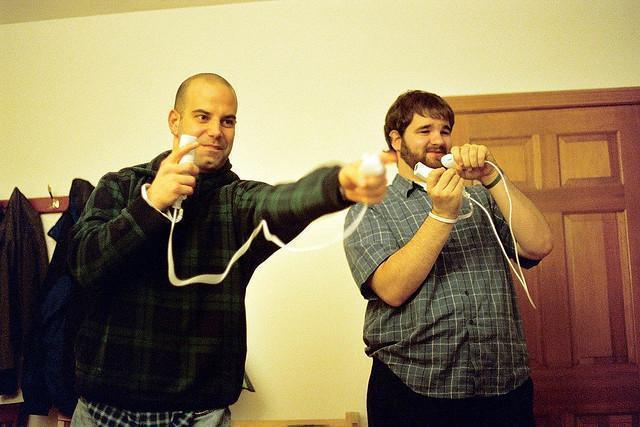What activity is the individual engaging in?
From the following four choices, select the correct answer to address the question.
Options: Boxing, climbing, running, taekwondo. Boxing. 